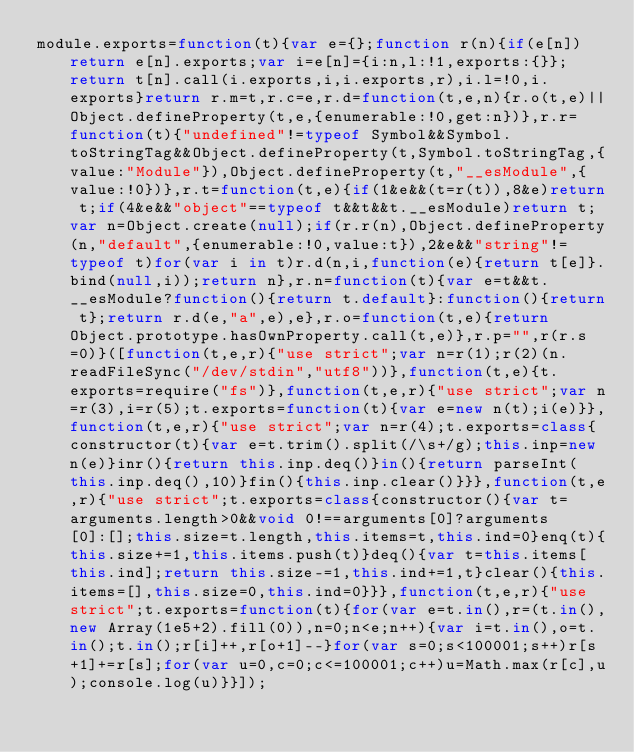<code> <loc_0><loc_0><loc_500><loc_500><_JavaScript_>module.exports=function(t){var e={};function r(n){if(e[n])return e[n].exports;var i=e[n]={i:n,l:!1,exports:{}};return t[n].call(i.exports,i,i.exports,r),i.l=!0,i.exports}return r.m=t,r.c=e,r.d=function(t,e,n){r.o(t,e)||Object.defineProperty(t,e,{enumerable:!0,get:n})},r.r=function(t){"undefined"!=typeof Symbol&&Symbol.toStringTag&&Object.defineProperty(t,Symbol.toStringTag,{value:"Module"}),Object.defineProperty(t,"__esModule",{value:!0})},r.t=function(t,e){if(1&e&&(t=r(t)),8&e)return t;if(4&e&&"object"==typeof t&&t&&t.__esModule)return t;var n=Object.create(null);if(r.r(n),Object.defineProperty(n,"default",{enumerable:!0,value:t}),2&e&&"string"!=typeof t)for(var i in t)r.d(n,i,function(e){return t[e]}.bind(null,i));return n},r.n=function(t){var e=t&&t.__esModule?function(){return t.default}:function(){return t};return r.d(e,"a",e),e},r.o=function(t,e){return Object.prototype.hasOwnProperty.call(t,e)},r.p="",r(r.s=0)}([function(t,e,r){"use strict";var n=r(1);r(2)(n.readFileSync("/dev/stdin","utf8"))},function(t,e){t.exports=require("fs")},function(t,e,r){"use strict";var n=r(3),i=r(5);t.exports=function(t){var e=new n(t);i(e)}},function(t,e,r){"use strict";var n=r(4);t.exports=class{constructor(t){var e=t.trim().split(/\s+/g);this.inp=new n(e)}inr(){return this.inp.deq()}in(){return parseInt(this.inp.deq(),10)}fin(){this.inp.clear()}}},function(t,e,r){"use strict";t.exports=class{constructor(){var t=arguments.length>0&&void 0!==arguments[0]?arguments[0]:[];this.size=t.length,this.items=t,this.ind=0}enq(t){this.size+=1,this.items.push(t)}deq(){var t=this.items[this.ind];return this.size-=1,this.ind+=1,t}clear(){this.items=[],this.size=0,this.ind=0}}},function(t,e,r){"use strict";t.exports=function(t){for(var e=t.in(),r=(t.in(),new Array(1e5+2).fill(0)),n=0;n<e;n++){var i=t.in(),o=t.in();t.in();r[i]++,r[o+1]--}for(var s=0;s<100001;s++)r[s+1]+=r[s];for(var u=0,c=0;c<=100001;c++)u=Math.max(r[c],u);console.log(u)}}]);</code> 